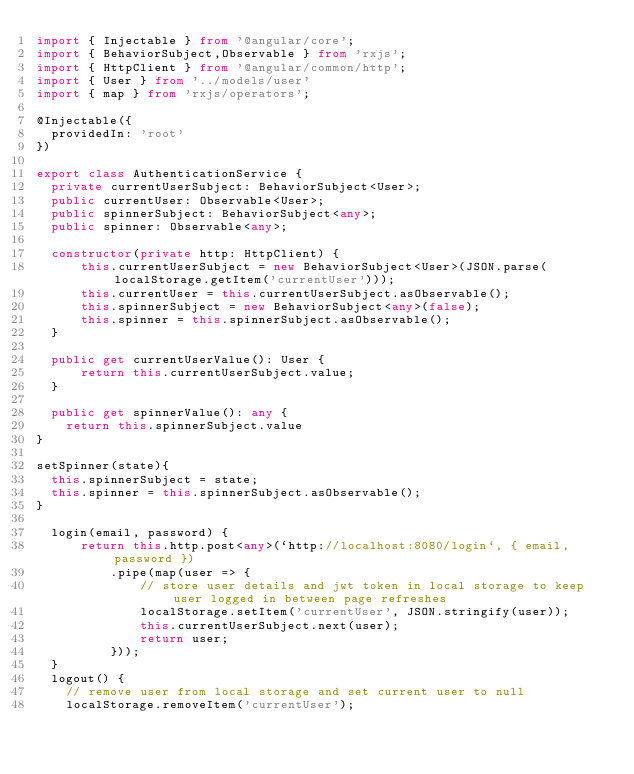<code> <loc_0><loc_0><loc_500><loc_500><_TypeScript_>import { Injectable } from '@angular/core';
import { BehaviorSubject,Observable } from 'rxjs';
import { HttpClient } from '@angular/common/http';
import { User } from '../models/user'
import { map } from 'rxjs/operators';

@Injectable({
  providedIn: 'root'
})

export class AuthenticationService {
  private currentUserSubject: BehaviorSubject<User>;
  public currentUser: Observable<User>;
  public spinnerSubject: BehaviorSubject<any>;
  public spinner: Observable<any>;

  constructor(private http: HttpClient) {
      this.currentUserSubject = new BehaviorSubject<User>(JSON.parse(localStorage.getItem('currentUser')));
      this.currentUser = this.currentUserSubject.asObservable();
      this.spinnerSubject = new BehaviorSubject<any>(false);
      this.spinner = this.spinnerSubject.asObservable();
  }

  public get currentUserValue(): User {
      return this.currentUserSubject.value;
  }

  public get spinnerValue(): any {
    return this.spinnerSubject.value
}

setSpinner(state){
  this.spinnerSubject = state;
  this.spinner = this.spinnerSubject.asObservable();
}

  login(email, password) {
      return this.http.post<any>(`http://localhost:8080/login`, { email, password })
          .pipe(map(user => {
              // store user details and jwt token in local storage to keep user logged in between page refreshes
              localStorage.setItem('currentUser', JSON.stringify(user));
              this.currentUserSubject.next(user);
              return user;
          }));
  }
  logout() {
    // remove user from local storage and set current user to null
    localStorage.removeItem('currentUser');</code> 